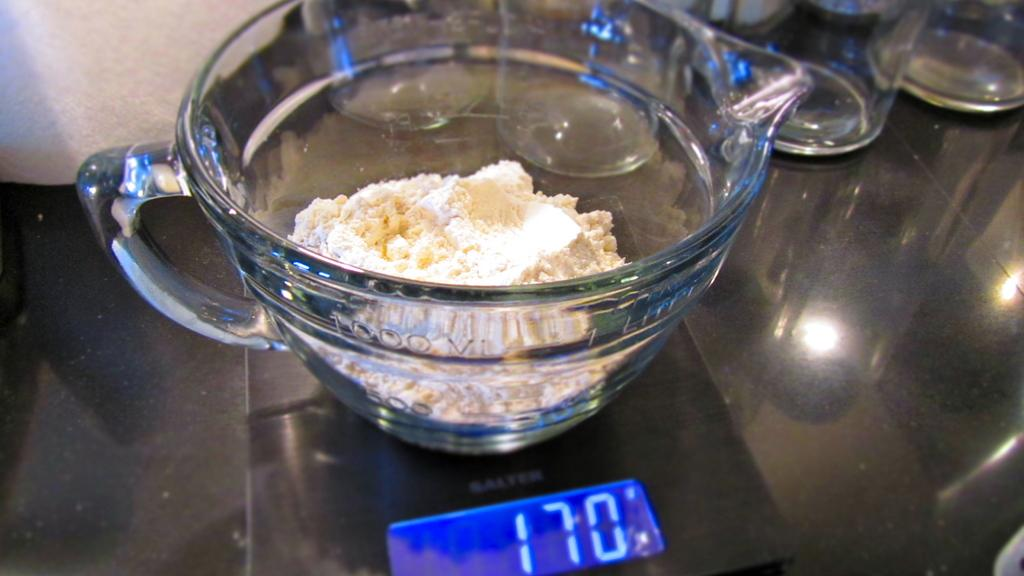<image>
Present a compact description of the photo's key features. some ingredients in a jug on a set of scales reading 170 